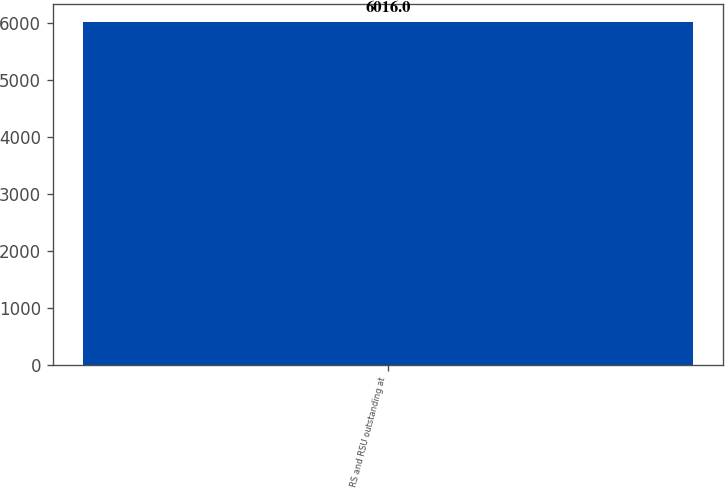Convert chart to OTSL. <chart><loc_0><loc_0><loc_500><loc_500><bar_chart><fcel>RS and RSU outstanding at<nl><fcel>6016<nl></chart> 